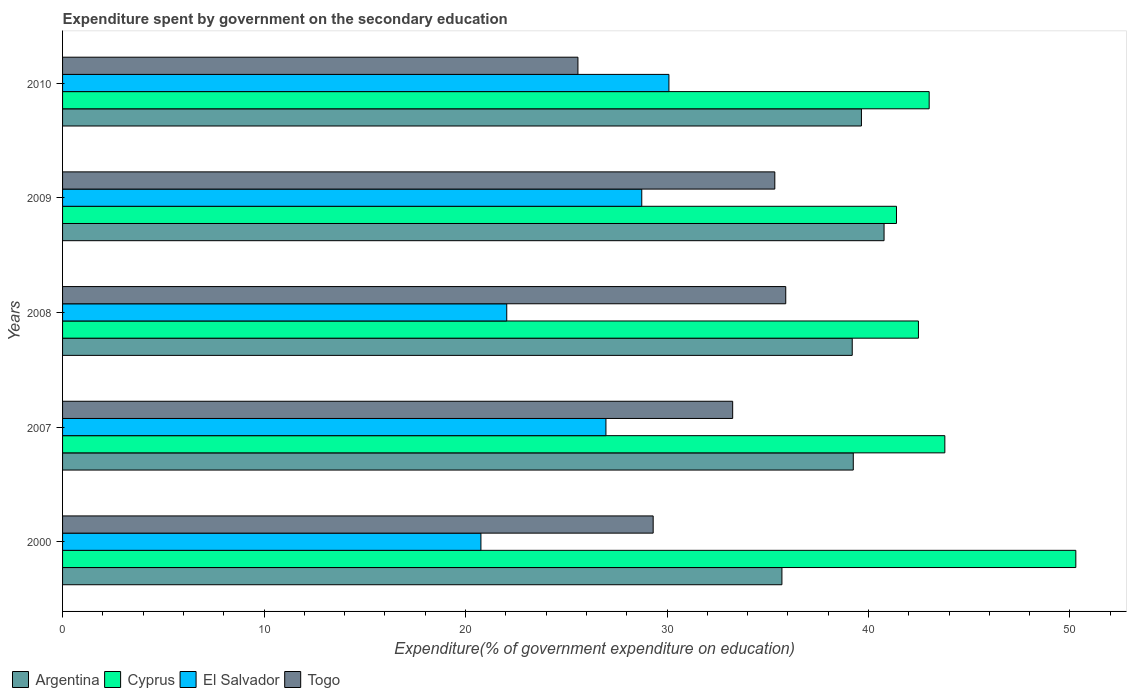How many groups of bars are there?
Your answer should be compact. 5. Are the number of bars per tick equal to the number of legend labels?
Your answer should be compact. Yes. Are the number of bars on each tick of the Y-axis equal?
Ensure brevity in your answer.  Yes. How many bars are there on the 2nd tick from the bottom?
Your answer should be compact. 4. In how many cases, is the number of bars for a given year not equal to the number of legend labels?
Make the answer very short. 0. What is the expenditure spent by government on the secondary education in El Salvador in 2000?
Offer a very short reply. 20.76. Across all years, what is the maximum expenditure spent by government on the secondary education in Togo?
Offer a very short reply. 35.89. Across all years, what is the minimum expenditure spent by government on the secondary education in Argentina?
Give a very brief answer. 35.7. In which year was the expenditure spent by government on the secondary education in Argentina minimum?
Offer a very short reply. 2000. What is the total expenditure spent by government on the secondary education in Togo in the graph?
Make the answer very short. 159.4. What is the difference between the expenditure spent by government on the secondary education in Togo in 2000 and that in 2007?
Make the answer very short. -3.95. What is the difference between the expenditure spent by government on the secondary education in Togo in 2010 and the expenditure spent by government on the secondary education in El Salvador in 2000?
Keep it short and to the point. 4.82. What is the average expenditure spent by government on the secondary education in Argentina per year?
Your answer should be compact. 38.91. In the year 2009, what is the difference between the expenditure spent by government on the secondary education in Cyprus and expenditure spent by government on the secondary education in Togo?
Give a very brief answer. 6.04. What is the ratio of the expenditure spent by government on the secondary education in Cyprus in 2000 to that in 2009?
Give a very brief answer. 1.22. Is the expenditure spent by government on the secondary education in Togo in 2000 less than that in 2008?
Give a very brief answer. Yes. What is the difference between the highest and the second highest expenditure spent by government on the secondary education in Cyprus?
Provide a short and direct response. 6.5. What is the difference between the highest and the lowest expenditure spent by government on the secondary education in El Salvador?
Keep it short and to the point. 9.33. Is the sum of the expenditure spent by government on the secondary education in Argentina in 2009 and 2010 greater than the maximum expenditure spent by government on the secondary education in Cyprus across all years?
Your answer should be compact. Yes. Is it the case that in every year, the sum of the expenditure spent by government on the secondary education in Cyprus and expenditure spent by government on the secondary education in Argentina is greater than the sum of expenditure spent by government on the secondary education in Togo and expenditure spent by government on the secondary education in El Salvador?
Give a very brief answer. Yes. What does the 3rd bar from the top in 2008 represents?
Make the answer very short. Cyprus. What does the 2nd bar from the bottom in 2009 represents?
Offer a terse response. Cyprus. Is it the case that in every year, the sum of the expenditure spent by government on the secondary education in Cyprus and expenditure spent by government on the secondary education in El Salvador is greater than the expenditure spent by government on the secondary education in Argentina?
Offer a terse response. Yes. Are all the bars in the graph horizontal?
Provide a succinct answer. Yes. How many years are there in the graph?
Ensure brevity in your answer.  5. How are the legend labels stacked?
Provide a succinct answer. Horizontal. What is the title of the graph?
Offer a very short reply. Expenditure spent by government on the secondary education. Does "Sierra Leone" appear as one of the legend labels in the graph?
Provide a short and direct response. No. What is the label or title of the X-axis?
Provide a short and direct response. Expenditure(% of government expenditure on education). What is the label or title of the Y-axis?
Keep it short and to the point. Years. What is the Expenditure(% of government expenditure on education) in Argentina in 2000?
Keep it short and to the point. 35.7. What is the Expenditure(% of government expenditure on education) in Cyprus in 2000?
Make the answer very short. 50.29. What is the Expenditure(% of government expenditure on education) in El Salvador in 2000?
Keep it short and to the point. 20.76. What is the Expenditure(% of government expenditure on education) in Togo in 2000?
Offer a very short reply. 29.31. What is the Expenditure(% of government expenditure on education) of Argentina in 2007?
Make the answer very short. 39.25. What is the Expenditure(% of government expenditure on education) of Cyprus in 2007?
Your response must be concise. 43.79. What is the Expenditure(% of government expenditure on education) in El Salvador in 2007?
Offer a terse response. 26.97. What is the Expenditure(% of government expenditure on education) of Togo in 2007?
Ensure brevity in your answer.  33.26. What is the Expenditure(% of government expenditure on education) in Argentina in 2008?
Your answer should be compact. 39.19. What is the Expenditure(% of government expenditure on education) of Cyprus in 2008?
Give a very brief answer. 42.48. What is the Expenditure(% of government expenditure on education) in El Salvador in 2008?
Ensure brevity in your answer.  22.05. What is the Expenditure(% of government expenditure on education) in Togo in 2008?
Offer a terse response. 35.89. What is the Expenditure(% of government expenditure on education) of Argentina in 2009?
Offer a very short reply. 40.77. What is the Expenditure(% of government expenditure on education) in Cyprus in 2009?
Your response must be concise. 41.39. What is the Expenditure(% of government expenditure on education) of El Salvador in 2009?
Ensure brevity in your answer.  28.75. What is the Expenditure(% of government expenditure on education) in Togo in 2009?
Keep it short and to the point. 35.35. What is the Expenditure(% of government expenditure on education) of Argentina in 2010?
Your response must be concise. 39.65. What is the Expenditure(% of government expenditure on education) of Cyprus in 2010?
Offer a terse response. 43.01. What is the Expenditure(% of government expenditure on education) of El Salvador in 2010?
Give a very brief answer. 30.09. What is the Expenditure(% of government expenditure on education) of Togo in 2010?
Provide a short and direct response. 25.58. Across all years, what is the maximum Expenditure(% of government expenditure on education) of Argentina?
Keep it short and to the point. 40.77. Across all years, what is the maximum Expenditure(% of government expenditure on education) in Cyprus?
Offer a terse response. 50.29. Across all years, what is the maximum Expenditure(% of government expenditure on education) of El Salvador?
Ensure brevity in your answer.  30.09. Across all years, what is the maximum Expenditure(% of government expenditure on education) in Togo?
Your response must be concise. 35.89. Across all years, what is the minimum Expenditure(% of government expenditure on education) of Argentina?
Your response must be concise. 35.7. Across all years, what is the minimum Expenditure(% of government expenditure on education) in Cyprus?
Keep it short and to the point. 41.39. Across all years, what is the minimum Expenditure(% of government expenditure on education) in El Salvador?
Keep it short and to the point. 20.76. Across all years, what is the minimum Expenditure(% of government expenditure on education) of Togo?
Provide a succinct answer. 25.58. What is the total Expenditure(% of government expenditure on education) in Argentina in the graph?
Keep it short and to the point. 194.57. What is the total Expenditure(% of government expenditure on education) in Cyprus in the graph?
Provide a succinct answer. 220.96. What is the total Expenditure(% of government expenditure on education) in El Salvador in the graph?
Make the answer very short. 128.62. What is the total Expenditure(% of government expenditure on education) in Togo in the graph?
Offer a very short reply. 159.4. What is the difference between the Expenditure(% of government expenditure on education) of Argentina in 2000 and that in 2007?
Offer a very short reply. -3.54. What is the difference between the Expenditure(% of government expenditure on education) of Cyprus in 2000 and that in 2007?
Your answer should be very brief. 6.5. What is the difference between the Expenditure(% of government expenditure on education) of El Salvador in 2000 and that in 2007?
Provide a short and direct response. -6.21. What is the difference between the Expenditure(% of government expenditure on education) of Togo in 2000 and that in 2007?
Provide a short and direct response. -3.95. What is the difference between the Expenditure(% of government expenditure on education) in Argentina in 2000 and that in 2008?
Provide a short and direct response. -3.49. What is the difference between the Expenditure(% of government expenditure on education) of Cyprus in 2000 and that in 2008?
Ensure brevity in your answer.  7.81. What is the difference between the Expenditure(% of government expenditure on education) of El Salvador in 2000 and that in 2008?
Give a very brief answer. -1.28. What is the difference between the Expenditure(% of government expenditure on education) in Togo in 2000 and that in 2008?
Make the answer very short. -6.58. What is the difference between the Expenditure(% of government expenditure on education) of Argentina in 2000 and that in 2009?
Provide a succinct answer. -5.07. What is the difference between the Expenditure(% of government expenditure on education) in Cyprus in 2000 and that in 2009?
Offer a very short reply. 8.9. What is the difference between the Expenditure(% of government expenditure on education) of El Salvador in 2000 and that in 2009?
Provide a short and direct response. -7.98. What is the difference between the Expenditure(% of government expenditure on education) of Togo in 2000 and that in 2009?
Make the answer very short. -6.04. What is the difference between the Expenditure(% of government expenditure on education) in Argentina in 2000 and that in 2010?
Your response must be concise. -3.95. What is the difference between the Expenditure(% of government expenditure on education) in Cyprus in 2000 and that in 2010?
Your answer should be very brief. 7.28. What is the difference between the Expenditure(% of government expenditure on education) of El Salvador in 2000 and that in 2010?
Provide a succinct answer. -9.33. What is the difference between the Expenditure(% of government expenditure on education) in Togo in 2000 and that in 2010?
Keep it short and to the point. 3.73. What is the difference between the Expenditure(% of government expenditure on education) in Argentina in 2007 and that in 2008?
Ensure brevity in your answer.  0.05. What is the difference between the Expenditure(% of government expenditure on education) in Cyprus in 2007 and that in 2008?
Ensure brevity in your answer.  1.31. What is the difference between the Expenditure(% of government expenditure on education) of El Salvador in 2007 and that in 2008?
Give a very brief answer. 4.92. What is the difference between the Expenditure(% of government expenditure on education) of Togo in 2007 and that in 2008?
Provide a short and direct response. -2.63. What is the difference between the Expenditure(% of government expenditure on education) in Argentina in 2007 and that in 2009?
Your answer should be compact. -1.53. What is the difference between the Expenditure(% of government expenditure on education) in Cyprus in 2007 and that in 2009?
Keep it short and to the point. 2.4. What is the difference between the Expenditure(% of government expenditure on education) of El Salvador in 2007 and that in 2009?
Provide a succinct answer. -1.78. What is the difference between the Expenditure(% of government expenditure on education) in Togo in 2007 and that in 2009?
Provide a short and direct response. -2.09. What is the difference between the Expenditure(% of government expenditure on education) in Argentina in 2007 and that in 2010?
Your answer should be very brief. -0.4. What is the difference between the Expenditure(% of government expenditure on education) in Cyprus in 2007 and that in 2010?
Offer a terse response. 0.78. What is the difference between the Expenditure(% of government expenditure on education) in El Salvador in 2007 and that in 2010?
Give a very brief answer. -3.13. What is the difference between the Expenditure(% of government expenditure on education) of Togo in 2007 and that in 2010?
Your answer should be very brief. 7.68. What is the difference between the Expenditure(% of government expenditure on education) of Argentina in 2008 and that in 2009?
Make the answer very short. -1.58. What is the difference between the Expenditure(% of government expenditure on education) in Cyprus in 2008 and that in 2009?
Keep it short and to the point. 1.09. What is the difference between the Expenditure(% of government expenditure on education) of El Salvador in 2008 and that in 2009?
Your answer should be compact. -6.7. What is the difference between the Expenditure(% of government expenditure on education) of Togo in 2008 and that in 2009?
Your answer should be compact. 0.54. What is the difference between the Expenditure(% of government expenditure on education) in Argentina in 2008 and that in 2010?
Give a very brief answer. -0.46. What is the difference between the Expenditure(% of government expenditure on education) in Cyprus in 2008 and that in 2010?
Offer a terse response. -0.53. What is the difference between the Expenditure(% of government expenditure on education) of El Salvador in 2008 and that in 2010?
Your answer should be very brief. -8.05. What is the difference between the Expenditure(% of government expenditure on education) in Togo in 2008 and that in 2010?
Offer a terse response. 10.31. What is the difference between the Expenditure(% of government expenditure on education) in Argentina in 2009 and that in 2010?
Give a very brief answer. 1.12. What is the difference between the Expenditure(% of government expenditure on education) in Cyprus in 2009 and that in 2010?
Provide a succinct answer. -1.62. What is the difference between the Expenditure(% of government expenditure on education) of El Salvador in 2009 and that in 2010?
Give a very brief answer. -1.35. What is the difference between the Expenditure(% of government expenditure on education) of Togo in 2009 and that in 2010?
Make the answer very short. 9.77. What is the difference between the Expenditure(% of government expenditure on education) of Argentina in 2000 and the Expenditure(% of government expenditure on education) of Cyprus in 2007?
Give a very brief answer. -8.09. What is the difference between the Expenditure(% of government expenditure on education) of Argentina in 2000 and the Expenditure(% of government expenditure on education) of El Salvador in 2007?
Provide a short and direct response. 8.73. What is the difference between the Expenditure(% of government expenditure on education) in Argentina in 2000 and the Expenditure(% of government expenditure on education) in Togo in 2007?
Your answer should be very brief. 2.44. What is the difference between the Expenditure(% of government expenditure on education) in Cyprus in 2000 and the Expenditure(% of government expenditure on education) in El Salvador in 2007?
Provide a short and direct response. 23.32. What is the difference between the Expenditure(% of government expenditure on education) of Cyprus in 2000 and the Expenditure(% of government expenditure on education) of Togo in 2007?
Your answer should be compact. 17.03. What is the difference between the Expenditure(% of government expenditure on education) of El Salvador in 2000 and the Expenditure(% of government expenditure on education) of Togo in 2007?
Provide a short and direct response. -12.49. What is the difference between the Expenditure(% of government expenditure on education) of Argentina in 2000 and the Expenditure(% of government expenditure on education) of Cyprus in 2008?
Make the answer very short. -6.78. What is the difference between the Expenditure(% of government expenditure on education) of Argentina in 2000 and the Expenditure(% of government expenditure on education) of El Salvador in 2008?
Your answer should be very brief. 13.66. What is the difference between the Expenditure(% of government expenditure on education) of Argentina in 2000 and the Expenditure(% of government expenditure on education) of Togo in 2008?
Keep it short and to the point. -0.19. What is the difference between the Expenditure(% of government expenditure on education) of Cyprus in 2000 and the Expenditure(% of government expenditure on education) of El Salvador in 2008?
Offer a terse response. 28.24. What is the difference between the Expenditure(% of government expenditure on education) in Cyprus in 2000 and the Expenditure(% of government expenditure on education) in Togo in 2008?
Give a very brief answer. 14.4. What is the difference between the Expenditure(% of government expenditure on education) of El Salvador in 2000 and the Expenditure(% of government expenditure on education) of Togo in 2008?
Keep it short and to the point. -15.13. What is the difference between the Expenditure(% of government expenditure on education) of Argentina in 2000 and the Expenditure(% of government expenditure on education) of Cyprus in 2009?
Offer a terse response. -5.69. What is the difference between the Expenditure(% of government expenditure on education) in Argentina in 2000 and the Expenditure(% of government expenditure on education) in El Salvador in 2009?
Provide a short and direct response. 6.96. What is the difference between the Expenditure(% of government expenditure on education) in Argentina in 2000 and the Expenditure(% of government expenditure on education) in Togo in 2009?
Keep it short and to the point. 0.35. What is the difference between the Expenditure(% of government expenditure on education) of Cyprus in 2000 and the Expenditure(% of government expenditure on education) of El Salvador in 2009?
Your answer should be compact. 21.54. What is the difference between the Expenditure(% of government expenditure on education) of Cyprus in 2000 and the Expenditure(% of government expenditure on education) of Togo in 2009?
Provide a short and direct response. 14.94. What is the difference between the Expenditure(% of government expenditure on education) of El Salvador in 2000 and the Expenditure(% of government expenditure on education) of Togo in 2009?
Give a very brief answer. -14.59. What is the difference between the Expenditure(% of government expenditure on education) of Argentina in 2000 and the Expenditure(% of government expenditure on education) of Cyprus in 2010?
Make the answer very short. -7.31. What is the difference between the Expenditure(% of government expenditure on education) in Argentina in 2000 and the Expenditure(% of government expenditure on education) in El Salvador in 2010?
Make the answer very short. 5.61. What is the difference between the Expenditure(% of government expenditure on education) in Argentina in 2000 and the Expenditure(% of government expenditure on education) in Togo in 2010?
Offer a very short reply. 10.12. What is the difference between the Expenditure(% of government expenditure on education) of Cyprus in 2000 and the Expenditure(% of government expenditure on education) of El Salvador in 2010?
Make the answer very short. 20.2. What is the difference between the Expenditure(% of government expenditure on education) of Cyprus in 2000 and the Expenditure(% of government expenditure on education) of Togo in 2010?
Your response must be concise. 24.71. What is the difference between the Expenditure(% of government expenditure on education) in El Salvador in 2000 and the Expenditure(% of government expenditure on education) in Togo in 2010?
Your response must be concise. -4.82. What is the difference between the Expenditure(% of government expenditure on education) of Argentina in 2007 and the Expenditure(% of government expenditure on education) of Cyprus in 2008?
Your answer should be compact. -3.23. What is the difference between the Expenditure(% of government expenditure on education) of Argentina in 2007 and the Expenditure(% of government expenditure on education) of El Salvador in 2008?
Your answer should be compact. 17.2. What is the difference between the Expenditure(% of government expenditure on education) in Argentina in 2007 and the Expenditure(% of government expenditure on education) in Togo in 2008?
Provide a succinct answer. 3.35. What is the difference between the Expenditure(% of government expenditure on education) in Cyprus in 2007 and the Expenditure(% of government expenditure on education) in El Salvador in 2008?
Provide a short and direct response. 21.74. What is the difference between the Expenditure(% of government expenditure on education) in Cyprus in 2007 and the Expenditure(% of government expenditure on education) in Togo in 2008?
Your answer should be very brief. 7.9. What is the difference between the Expenditure(% of government expenditure on education) of El Salvador in 2007 and the Expenditure(% of government expenditure on education) of Togo in 2008?
Ensure brevity in your answer.  -8.92. What is the difference between the Expenditure(% of government expenditure on education) of Argentina in 2007 and the Expenditure(% of government expenditure on education) of Cyprus in 2009?
Make the answer very short. -2.14. What is the difference between the Expenditure(% of government expenditure on education) in Argentina in 2007 and the Expenditure(% of government expenditure on education) in El Salvador in 2009?
Your answer should be compact. 10.5. What is the difference between the Expenditure(% of government expenditure on education) of Argentina in 2007 and the Expenditure(% of government expenditure on education) of Togo in 2009?
Your answer should be compact. 3.9. What is the difference between the Expenditure(% of government expenditure on education) in Cyprus in 2007 and the Expenditure(% of government expenditure on education) in El Salvador in 2009?
Make the answer very short. 15.04. What is the difference between the Expenditure(% of government expenditure on education) in Cyprus in 2007 and the Expenditure(% of government expenditure on education) in Togo in 2009?
Ensure brevity in your answer.  8.44. What is the difference between the Expenditure(% of government expenditure on education) of El Salvador in 2007 and the Expenditure(% of government expenditure on education) of Togo in 2009?
Give a very brief answer. -8.38. What is the difference between the Expenditure(% of government expenditure on education) of Argentina in 2007 and the Expenditure(% of government expenditure on education) of Cyprus in 2010?
Offer a very short reply. -3.77. What is the difference between the Expenditure(% of government expenditure on education) in Argentina in 2007 and the Expenditure(% of government expenditure on education) in El Salvador in 2010?
Your answer should be compact. 9.15. What is the difference between the Expenditure(% of government expenditure on education) of Argentina in 2007 and the Expenditure(% of government expenditure on education) of Togo in 2010?
Your answer should be very brief. 13.67. What is the difference between the Expenditure(% of government expenditure on education) in Cyprus in 2007 and the Expenditure(% of government expenditure on education) in El Salvador in 2010?
Give a very brief answer. 13.7. What is the difference between the Expenditure(% of government expenditure on education) in Cyprus in 2007 and the Expenditure(% of government expenditure on education) in Togo in 2010?
Provide a succinct answer. 18.21. What is the difference between the Expenditure(% of government expenditure on education) of El Salvador in 2007 and the Expenditure(% of government expenditure on education) of Togo in 2010?
Keep it short and to the point. 1.39. What is the difference between the Expenditure(% of government expenditure on education) in Argentina in 2008 and the Expenditure(% of government expenditure on education) in Cyprus in 2009?
Offer a terse response. -2.2. What is the difference between the Expenditure(% of government expenditure on education) in Argentina in 2008 and the Expenditure(% of government expenditure on education) in El Salvador in 2009?
Offer a very short reply. 10.45. What is the difference between the Expenditure(% of government expenditure on education) in Argentina in 2008 and the Expenditure(% of government expenditure on education) in Togo in 2009?
Make the answer very short. 3.84. What is the difference between the Expenditure(% of government expenditure on education) of Cyprus in 2008 and the Expenditure(% of government expenditure on education) of El Salvador in 2009?
Offer a very short reply. 13.73. What is the difference between the Expenditure(% of government expenditure on education) in Cyprus in 2008 and the Expenditure(% of government expenditure on education) in Togo in 2009?
Your answer should be compact. 7.13. What is the difference between the Expenditure(% of government expenditure on education) of El Salvador in 2008 and the Expenditure(% of government expenditure on education) of Togo in 2009?
Offer a terse response. -13.3. What is the difference between the Expenditure(% of government expenditure on education) in Argentina in 2008 and the Expenditure(% of government expenditure on education) in Cyprus in 2010?
Ensure brevity in your answer.  -3.82. What is the difference between the Expenditure(% of government expenditure on education) of Argentina in 2008 and the Expenditure(% of government expenditure on education) of El Salvador in 2010?
Give a very brief answer. 9.1. What is the difference between the Expenditure(% of government expenditure on education) of Argentina in 2008 and the Expenditure(% of government expenditure on education) of Togo in 2010?
Provide a succinct answer. 13.61. What is the difference between the Expenditure(% of government expenditure on education) in Cyprus in 2008 and the Expenditure(% of government expenditure on education) in El Salvador in 2010?
Your answer should be compact. 12.38. What is the difference between the Expenditure(% of government expenditure on education) in Cyprus in 2008 and the Expenditure(% of government expenditure on education) in Togo in 2010?
Offer a very short reply. 16.9. What is the difference between the Expenditure(% of government expenditure on education) in El Salvador in 2008 and the Expenditure(% of government expenditure on education) in Togo in 2010?
Provide a short and direct response. -3.53. What is the difference between the Expenditure(% of government expenditure on education) of Argentina in 2009 and the Expenditure(% of government expenditure on education) of Cyprus in 2010?
Give a very brief answer. -2.24. What is the difference between the Expenditure(% of government expenditure on education) of Argentina in 2009 and the Expenditure(% of government expenditure on education) of El Salvador in 2010?
Your answer should be compact. 10.68. What is the difference between the Expenditure(% of government expenditure on education) of Argentina in 2009 and the Expenditure(% of government expenditure on education) of Togo in 2010?
Your response must be concise. 15.19. What is the difference between the Expenditure(% of government expenditure on education) in Cyprus in 2009 and the Expenditure(% of government expenditure on education) in El Salvador in 2010?
Your response must be concise. 11.29. What is the difference between the Expenditure(% of government expenditure on education) in Cyprus in 2009 and the Expenditure(% of government expenditure on education) in Togo in 2010?
Provide a short and direct response. 15.81. What is the difference between the Expenditure(% of government expenditure on education) of El Salvador in 2009 and the Expenditure(% of government expenditure on education) of Togo in 2010?
Your answer should be compact. 3.17. What is the average Expenditure(% of government expenditure on education) in Argentina per year?
Your response must be concise. 38.91. What is the average Expenditure(% of government expenditure on education) in Cyprus per year?
Your answer should be compact. 44.19. What is the average Expenditure(% of government expenditure on education) in El Salvador per year?
Your answer should be very brief. 25.72. What is the average Expenditure(% of government expenditure on education) of Togo per year?
Offer a very short reply. 31.88. In the year 2000, what is the difference between the Expenditure(% of government expenditure on education) in Argentina and Expenditure(% of government expenditure on education) in Cyprus?
Provide a short and direct response. -14.59. In the year 2000, what is the difference between the Expenditure(% of government expenditure on education) in Argentina and Expenditure(% of government expenditure on education) in El Salvador?
Offer a terse response. 14.94. In the year 2000, what is the difference between the Expenditure(% of government expenditure on education) of Argentina and Expenditure(% of government expenditure on education) of Togo?
Your response must be concise. 6.39. In the year 2000, what is the difference between the Expenditure(% of government expenditure on education) of Cyprus and Expenditure(% of government expenditure on education) of El Salvador?
Your answer should be compact. 29.53. In the year 2000, what is the difference between the Expenditure(% of government expenditure on education) of Cyprus and Expenditure(% of government expenditure on education) of Togo?
Your answer should be compact. 20.98. In the year 2000, what is the difference between the Expenditure(% of government expenditure on education) of El Salvador and Expenditure(% of government expenditure on education) of Togo?
Ensure brevity in your answer.  -8.55. In the year 2007, what is the difference between the Expenditure(% of government expenditure on education) of Argentina and Expenditure(% of government expenditure on education) of Cyprus?
Provide a succinct answer. -4.54. In the year 2007, what is the difference between the Expenditure(% of government expenditure on education) of Argentina and Expenditure(% of government expenditure on education) of El Salvador?
Your response must be concise. 12.28. In the year 2007, what is the difference between the Expenditure(% of government expenditure on education) of Argentina and Expenditure(% of government expenditure on education) of Togo?
Your answer should be compact. 5.99. In the year 2007, what is the difference between the Expenditure(% of government expenditure on education) of Cyprus and Expenditure(% of government expenditure on education) of El Salvador?
Your answer should be very brief. 16.82. In the year 2007, what is the difference between the Expenditure(% of government expenditure on education) of Cyprus and Expenditure(% of government expenditure on education) of Togo?
Keep it short and to the point. 10.53. In the year 2007, what is the difference between the Expenditure(% of government expenditure on education) of El Salvador and Expenditure(% of government expenditure on education) of Togo?
Offer a terse response. -6.29. In the year 2008, what is the difference between the Expenditure(% of government expenditure on education) of Argentina and Expenditure(% of government expenditure on education) of Cyprus?
Give a very brief answer. -3.29. In the year 2008, what is the difference between the Expenditure(% of government expenditure on education) in Argentina and Expenditure(% of government expenditure on education) in El Salvador?
Your answer should be very brief. 17.15. In the year 2008, what is the difference between the Expenditure(% of government expenditure on education) in Argentina and Expenditure(% of government expenditure on education) in Togo?
Provide a succinct answer. 3.3. In the year 2008, what is the difference between the Expenditure(% of government expenditure on education) of Cyprus and Expenditure(% of government expenditure on education) of El Salvador?
Offer a very short reply. 20.43. In the year 2008, what is the difference between the Expenditure(% of government expenditure on education) in Cyprus and Expenditure(% of government expenditure on education) in Togo?
Offer a terse response. 6.59. In the year 2008, what is the difference between the Expenditure(% of government expenditure on education) of El Salvador and Expenditure(% of government expenditure on education) of Togo?
Offer a very short reply. -13.85. In the year 2009, what is the difference between the Expenditure(% of government expenditure on education) in Argentina and Expenditure(% of government expenditure on education) in Cyprus?
Offer a terse response. -0.62. In the year 2009, what is the difference between the Expenditure(% of government expenditure on education) in Argentina and Expenditure(% of government expenditure on education) in El Salvador?
Your answer should be compact. 12.03. In the year 2009, what is the difference between the Expenditure(% of government expenditure on education) of Argentina and Expenditure(% of government expenditure on education) of Togo?
Keep it short and to the point. 5.42. In the year 2009, what is the difference between the Expenditure(% of government expenditure on education) in Cyprus and Expenditure(% of government expenditure on education) in El Salvador?
Your response must be concise. 12.64. In the year 2009, what is the difference between the Expenditure(% of government expenditure on education) in Cyprus and Expenditure(% of government expenditure on education) in Togo?
Provide a succinct answer. 6.04. In the year 2009, what is the difference between the Expenditure(% of government expenditure on education) of El Salvador and Expenditure(% of government expenditure on education) of Togo?
Offer a terse response. -6.6. In the year 2010, what is the difference between the Expenditure(% of government expenditure on education) in Argentina and Expenditure(% of government expenditure on education) in Cyprus?
Provide a succinct answer. -3.36. In the year 2010, what is the difference between the Expenditure(% of government expenditure on education) of Argentina and Expenditure(% of government expenditure on education) of El Salvador?
Make the answer very short. 9.56. In the year 2010, what is the difference between the Expenditure(% of government expenditure on education) of Argentina and Expenditure(% of government expenditure on education) of Togo?
Provide a short and direct response. 14.07. In the year 2010, what is the difference between the Expenditure(% of government expenditure on education) of Cyprus and Expenditure(% of government expenditure on education) of El Salvador?
Your response must be concise. 12.92. In the year 2010, what is the difference between the Expenditure(% of government expenditure on education) of Cyprus and Expenditure(% of government expenditure on education) of Togo?
Keep it short and to the point. 17.43. In the year 2010, what is the difference between the Expenditure(% of government expenditure on education) of El Salvador and Expenditure(% of government expenditure on education) of Togo?
Your answer should be very brief. 4.52. What is the ratio of the Expenditure(% of government expenditure on education) in Argentina in 2000 to that in 2007?
Your response must be concise. 0.91. What is the ratio of the Expenditure(% of government expenditure on education) of Cyprus in 2000 to that in 2007?
Your answer should be compact. 1.15. What is the ratio of the Expenditure(% of government expenditure on education) in El Salvador in 2000 to that in 2007?
Make the answer very short. 0.77. What is the ratio of the Expenditure(% of government expenditure on education) of Togo in 2000 to that in 2007?
Your answer should be very brief. 0.88. What is the ratio of the Expenditure(% of government expenditure on education) of Argentina in 2000 to that in 2008?
Keep it short and to the point. 0.91. What is the ratio of the Expenditure(% of government expenditure on education) in Cyprus in 2000 to that in 2008?
Your response must be concise. 1.18. What is the ratio of the Expenditure(% of government expenditure on education) in El Salvador in 2000 to that in 2008?
Offer a terse response. 0.94. What is the ratio of the Expenditure(% of government expenditure on education) in Togo in 2000 to that in 2008?
Ensure brevity in your answer.  0.82. What is the ratio of the Expenditure(% of government expenditure on education) of Argentina in 2000 to that in 2009?
Provide a succinct answer. 0.88. What is the ratio of the Expenditure(% of government expenditure on education) in Cyprus in 2000 to that in 2009?
Your response must be concise. 1.22. What is the ratio of the Expenditure(% of government expenditure on education) in El Salvador in 2000 to that in 2009?
Provide a short and direct response. 0.72. What is the ratio of the Expenditure(% of government expenditure on education) in Togo in 2000 to that in 2009?
Provide a succinct answer. 0.83. What is the ratio of the Expenditure(% of government expenditure on education) in Argentina in 2000 to that in 2010?
Give a very brief answer. 0.9. What is the ratio of the Expenditure(% of government expenditure on education) in Cyprus in 2000 to that in 2010?
Provide a succinct answer. 1.17. What is the ratio of the Expenditure(% of government expenditure on education) in El Salvador in 2000 to that in 2010?
Provide a succinct answer. 0.69. What is the ratio of the Expenditure(% of government expenditure on education) in Togo in 2000 to that in 2010?
Offer a terse response. 1.15. What is the ratio of the Expenditure(% of government expenditure on education) in Cyprus in 2007 to that in 2008?
Your answer should be compact. 1.03. What is the ratio of the Expenditure(% of government expenditure on education) in El Salvador in 2007 to that in 2008?
Your response must be concise. 1.22. What is the ratio of the Expenditure(% of government expenditure on education) in Togo in 2007 to that in 2008?
Ensure brevity in your answer.  0.93. What is the ratio of the Expenditure(% of government expenditure on education) in Argentina in 2007 to that in 2009?
Ensure brevity in your answer.  0.96. What is the ratio of the Expenditure(% of government expenditure on education) in Cyprus in 2007 to that in 2009?
Keep it short and to the point. 1.06. What is the ratio of the Expenditure(% of government expenditure on education) in El Salvador in 2007 to that in 2009?
Offer a very short reply. 0.94. What is the ratio of the Expenditure(% of government expenditure on education) of Togo in 2007 to that in 2009?
Provide a succinct answer. 0.94. What is the ratio of the Expenditure(% of government expenditure on education) in Cyprus in 2007 to that in 2010?
Your response must be concise. 1.02. What is the ratio of the Expenditure(% of government expenditure on education) in El Salvador in 2007 to that in 2010?
Provide a short and direct response. 0.9. What is the ratio of the Expenditure(% of government expenditure on education) in Togo in 2007 to that in 2010?
Ensure brevity in your answer.  1.3. What is the ratio of the Expenditure(% of government expenditure on education) of Argentina in 2008 to that in 2009?
Give a very brief answer. 0.96. What is the ratio of the Expenditure(% of government expenditure on education) of Cyprus in 2008 to that in 2009?
Your response must be concise. 1.03. What is the ratio of the Expenditure(% of government expenditure on education) in El Salvador in 2008 to that in 2009?
Your response must be concise. 0.77. What is the ratio of the Expenditure(% of government expenditure on education) in Togo in 2008 to that in 2009?
Your answer should be very brief. 1.02. What is the ratio of the Expenditure(% of government expenditure on education) in Argentina in 2008 to that in 2010?
Provide a succinct answer. 0.99. What is the ratio of the Expenditure(% of government expenditure on education) in Cyprus in 2008 to that in 2010?
Provide a short and direct response. 0.99. What is the ratio of the Expenditure(% of government expenditure on education) of El Salvador in 2008 to that in 2010?
Offer a terse response. 0.73. What is the ratio of the Expenditure(% of government expenditure on education) in Togo in 2008 to that in 2010?
Your response must be concise. 1.4. What is the ratio of the Expenditure(% of government expenditure on education) in Argentina in 2009 to that in 2010?
Make the answer very short. 1.03. What is the ratio of the Expenditure(% of government expenditure on education) in Cyprus in 2009 to that in 2010?
Make the answer very short. 0.96. What is the ratio of the Expenditure(% of government expenditure on education) of El Salvador in 2009 to that in 2010?
Offer a terse response. 0.96. What is the ratio of the Expenditure(% of government expenditure on education) of Togo in 2009 to that in 2010?
Provide a short and direct response. 1.38. What is the difference between the highest and the second highest Expenditure(% of government expenditure on education) of Argentina?
Give a very brief answer. 1.12. What is the difference between the highest and the second highest Expenditure(% of government expenditure on education) in Cyprus?
Make the answer very short. 6.5. What is the difference between the highest and the second highest Expenditure(% of government expenditure on education) in El Salvador?
Provide a short and direct response. 1.35. What is the difference between the highest and the second highest Expenditure(% of government expenditure on education) in Togo?
Offer a very short reply. 0.54. What is the difference between the highest and the lowest Expenditure(% of government expenditure on education) in Argentina?
Keep it short and to the point. 5.07. What is the difference between the highest and the lowest Expenditure(% of government expenditure on education) of Cyprus?
Provide a succinct answer. 8.9. What is the difference between the highest and the lowest Expenditure(% of government expenditure on education) of El Salvador?
Provide a succinct answer. 9.33. What is the difference between the highest and the lowest Expenditure(% of government expenditure on education) in Togo?
Offer a terse response. 10.31. 